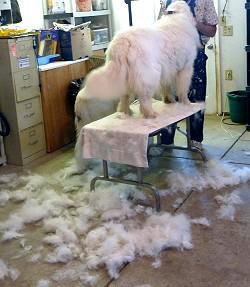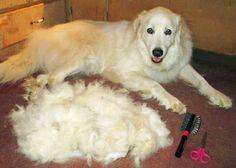The first image is the image on the left, the second image is the image on the right. For the images shown, is this caption "There are piles of fur on the floor in at least one picture." true? Answer yes or no. Yes. 